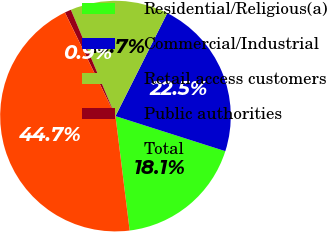Convert chart to OTSL. <chart><loc_0><loc_0><loc_500><loc_500><pie_chart><fcel>Residential/Religious(a)<fcel>Commercial/Industrial<fcel>Retail access customers<fcel>Public authorities<fcel>Total<nl><fcel>18.12%<fcel>22.5%<fcel>13.74%<fcel>0.9%<fcel>44.74%<nl></chart> 